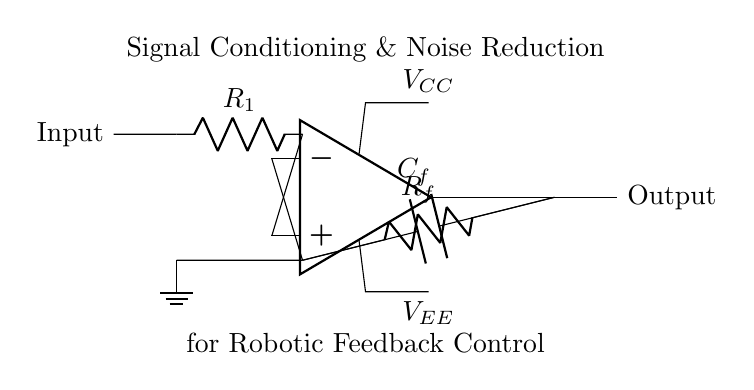What component is used for feedback in this circuit? The feedback in the circuit is provided by the resistor labeled R_f, which connects the output of the operational amplifier to the inverting terminal.
Answer: R_f What does the capacitor C_f do in this circuit? The capacitor C_f is used for noise reduction by filtering out high-frequency noise from the feedback loop, allowing for a cleaner signal at the output.
Answer: Noise reduction What is the function of the operational amplifier in this circuit? The operational amplifier amplifies the difference between the input voltage at the non-inverting terminal and the inverting terminal, thereby conditioning the signal for better feedback control in robotic systems.
Answer: Amplification How many resistors are present in the circuit? There are two resistors in the circuit: R_1 and R_f, used for input and feedback respectively.
Answer: 2 Which terminal of the operational amplifier is connected to the input signal? The non-inverting terminal of the operational amplifier, denoted by the positive input symbol, is connected to the input signal through the resistor R_1.
Answer: Non-inverting terminal What is the role of the voltage supplies V_CC and V_EE? V_CC provides the positive supply voltage for the operational amplifier and V_EE supplies the negative voltage, ensuring the op-amp operates properly within its voltage range.
Answer: Power supply 